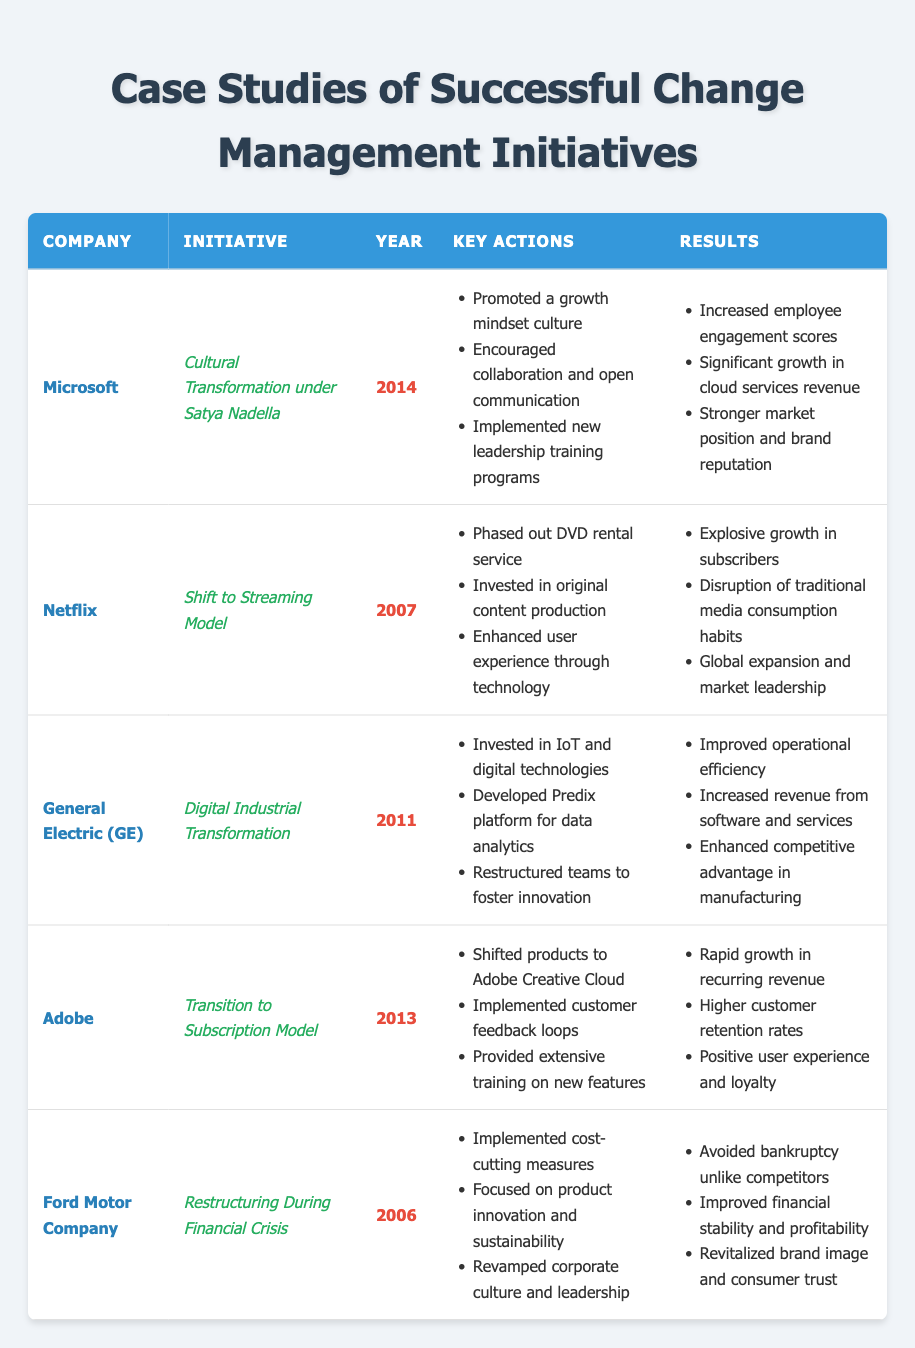What year did Ford Motor Company restructure during a financial crisis? The table indicates the year listed for Ford Motor Company's initiative related to restructuring is 2006.
Answer: 2006 Which company implemented a cultural transformation in 2014? The table shows that Microsoft is the company that undertook a cultural transformation initiative under Satya Nadella in 2014.
Answer: Microsoft Did Adobe implement customer feedback loops during their transition to a subscription model? According to the table, one of the key actions noted for Adobe during their initiative was the implementation of customer feedback loops, confirming that they did so.
Answer: Yes What are the three key actions taken by Netflix in its shift to a streaming model? The table lists Netflix's key actions during the initiative, which include phasing out the DVD rental service, investing in original content production, and enhancing user experience through technology.
Answer: Phased out DVD rentals, invested in original content, enhanced user experience Which company saw significant growth in subscribers as a result of their change initiative? By examining the results of the Netflix initiative, it is stated that they experienced explosive growth in subscribers due to their shift to streaming.
Answer: Netflix What were the results of General Electric's digital industrial transformation? The table outlines specific results for GE, including improved operational efficiency, increased revenue from software and services, and enhanced competitive advantage in manufacturing.
Answer: Improved efficiency, increased revenue, enhanced competitive advantage Was there a focus on sustainability in Ford's restructuring initiative? The Ford Motor Company's key actions included focusing on product innovation and sustainability, therefore indicating that sustainability was a focus during their restructuring initiative.
Answer: Yes Among the companies listed, which one transitioned to a subscription model first? The table highlights that Adobe transitioned to a subscription model in 2013, while other companies had different initiatives in other years. Hence, Adobe was the first among those listed to make this transition in the given timeline.
Answer: Adobe How many companies listed made a significant change in their business model? By reviewing the initiatives, both Netflix (shift to streaming) and Adobe (transition to subscription) made significant changes in their respective business models. Therefore, a total of two companies made such changes.
Answer: 2 What year did Microsoft begin its cultural transformation? From the table, it can be seen that Microsoft's cultural transformation initiative started in 2014.
Answer: 2014 Did Ford Motor Company improve its financial stability after their restructuring initiative? The results for Ford indicate that the restructuring led to improved financial stability and profitability, confirming that their efforts were successful in this aspect.
Answer: Yes 